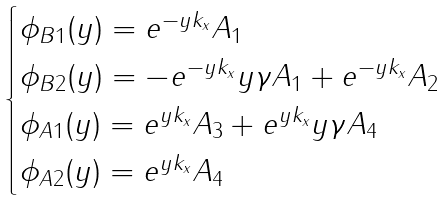<formula> <loc_0><loc_0><loc_500><loc_500>\begin{cases} \phi _ { B 1 } ( y ) = e ^ { - y k _ { x } } A _ { 1 } \\ \phi _ { B 2 } ( y ) = - e ^ { - y k _ { x } } y \gamma A _ { 1 } + e ^ { - y k _ { x } } A _ { 2 } \\ \phi _ { A 1 } ( y ) = e ^ { y k _ { x } } A _ { 3 } + e ^ { y k _ { x } } y \gamma A _ { 4 } \\ \phi _ { A 2 } ( y ) = e ^ { y k _ { x } } A _ { 4 } \end{cases}</formula> 